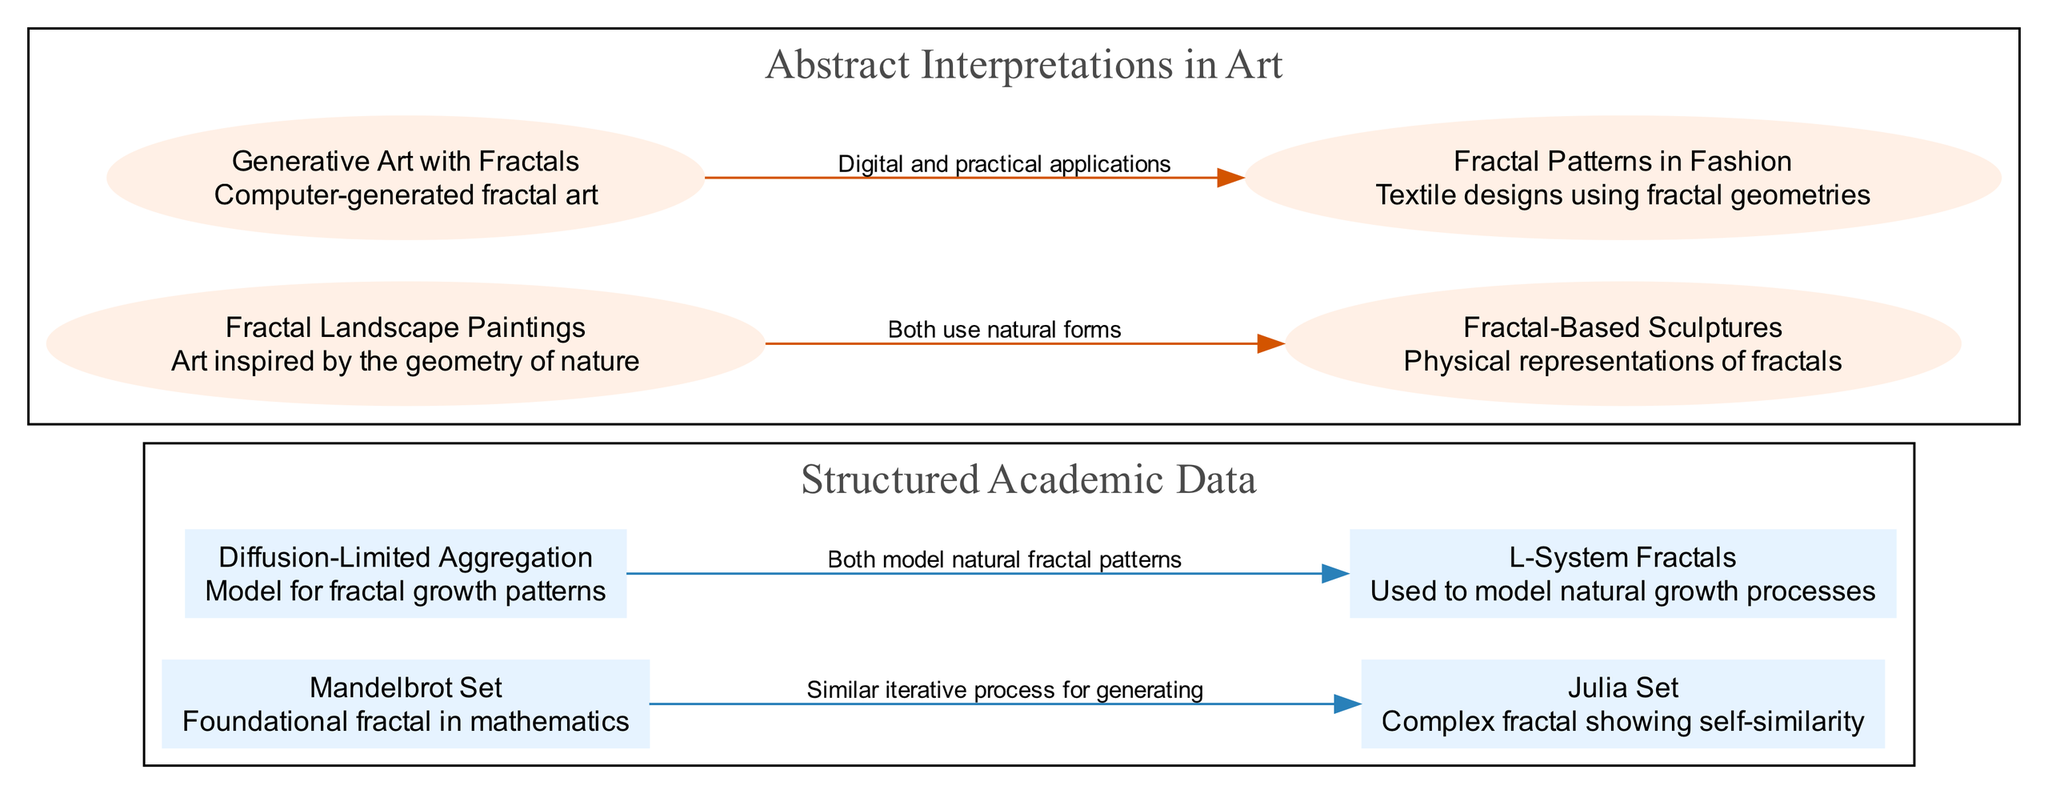What is the first node in the Structured Academic Data section? The first node listed under the Structured Academic Data section is the "Mandelbrot Set."
Answer: Mandelbrot Set How many edges are in the Abstract Interpretations in Art section? There are two edges listed in the Abstract Interpretations in Art section, connecting Fractal Landscape Paintings to Fractal-Based Sculptures, and Generative Art with Fractals to Fractal Patterns in Fashion.
Answer: 2 What does the edge from Diffusion-Limited Aggregation to L-System Fractals represent? The edge indicates both models, Diffusion-Limited Aggregation and L-System Fractals, are used to model natural fractal patterns.
Answer: Both model natural fractal patterns Which node in the Structured Academic Data section is used to model natural growth processes? The node is "L-System Fractals," which is associated with modeling natural growth processes.
Answer: L-System Fractals What is the primary theme connecting Fractal Landscape Paintings and Fractal-Based Sculptures? The main theme connecting these two nodes is that both use natural forms in their artistic representations.
Answer: Both use natural forms What is the relationship between Generative Art with Fractals and Fractal Patterns in Fashion? The relationship indicates that Generative Art with Fractals leads to practical applications in Fractal Patterns in Fashion.
Answer: Digital and practical applications Which node describes complex fractals showing self-similarity? The node that describes this concept is the "Julia Set."
Answer: Julia Set How many nodes are in the Structured Academic Data section? There are four nodes described in the Structured Academic Data section: Mandelbrot Set, Julia Set, Diffusion-Limited Aggregation, and L-System Fractals.
Answer: 4 Which two sections are being compared in this diagram? The diagram compares "Structured Academic Data" and "Abstract Interpretations in Art."
Answer: Structured Academic Data and Abstract Interpretations in Art 